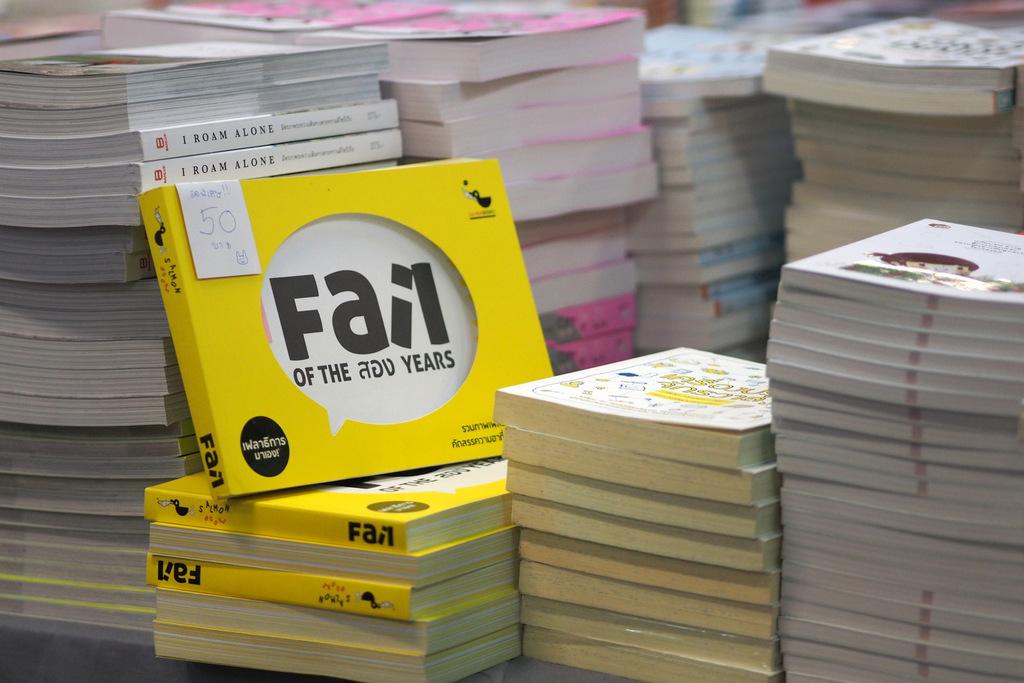What is the title of the yellow book?
Provide a short and direct response. Fail. 